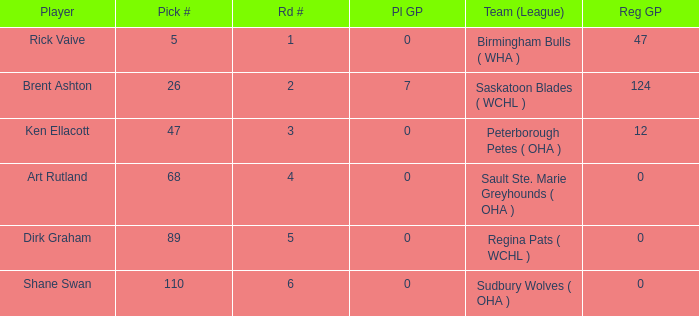How many reg GP for rick vaive in round 1? None. 